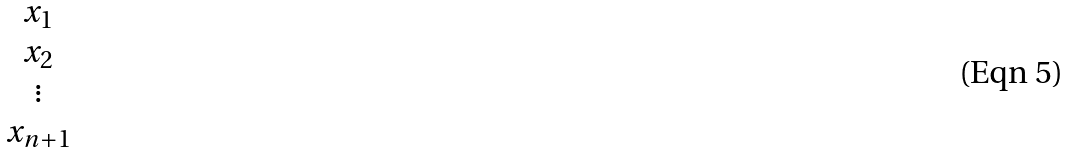Convert formula to latex. <formula><loc_0><loc_0><loc_500><loc_500>\begin{matrix} x _ { 1 } \\ x _ { 2 } \\ \vdots \\ x _ { n + 1 } \\ \end{matrix}</formula> 